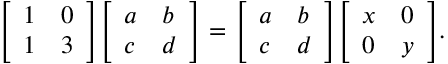<formula> <loc_0><loc_0><loc_500><loc_500>{ \left [ \begin{array} { l l } { 1 } & { 0 } \\ { 1 } & { 3 } \end{array} \right ] } { \left [ \begin{array} { l l } { a } & { b } \\ { c } & { d } \end{array} \right ] } = { \left [ \begin{array} { l l } { a } & { b } \\ { c } & { d } \end{array} \right ] } { \left [ \begin{array} { l l } { x } & { 0 } \\ { 0 } & { y } \end{array} \right ] } .</formula> 